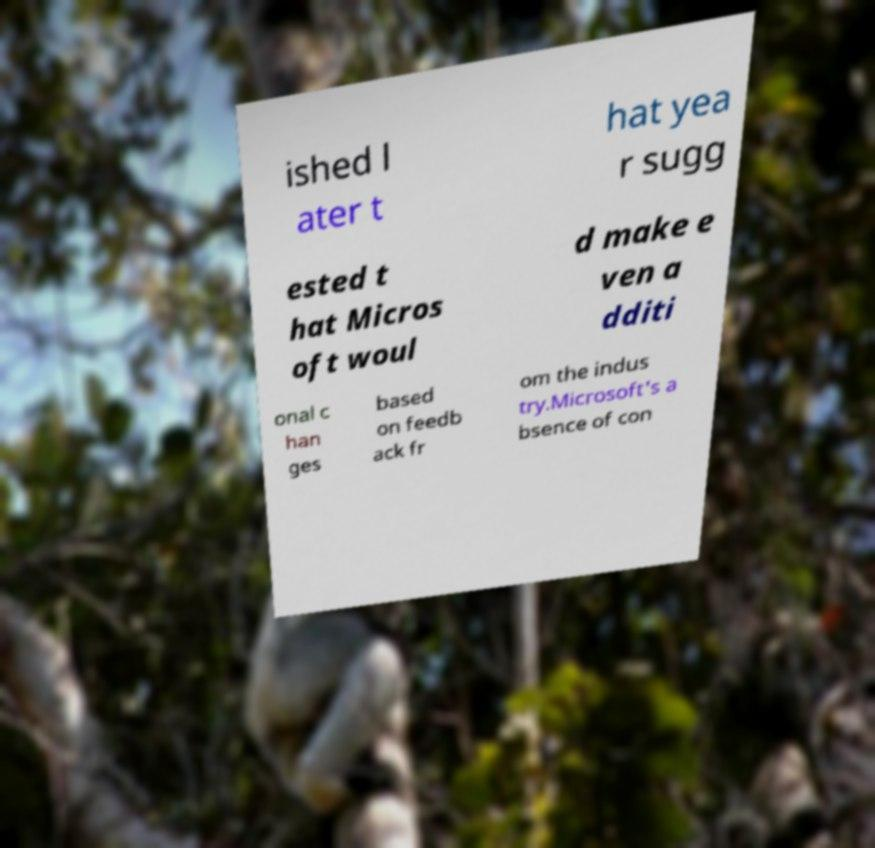For documentation purposes, I need the text within this image transcribed. Could you provide that? ished l ater t hat yea r sugg ested t hat Micros oft woul d make e ven a dditi onal c han ges based on feedb ack fr om the indus try.Microsoft's a bsence of con 